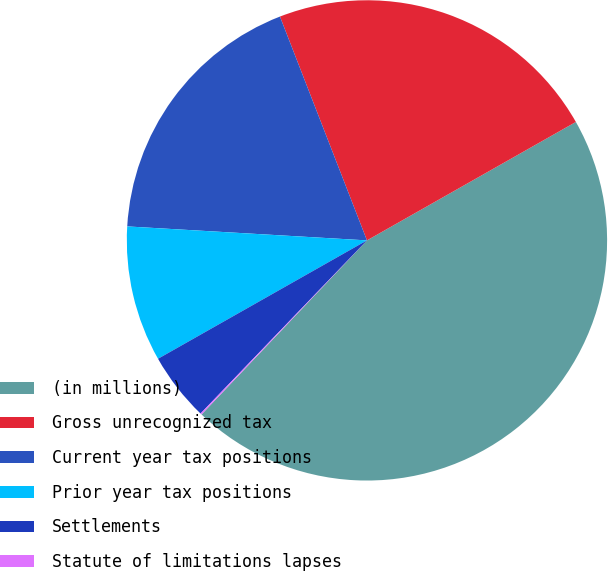Convert chart to OTSL. <chart><loc_0><loc_0><loc_500><loc_500><pie_chart><fcel>(in millions)<fcel>Gross unrecognized tax<fcel>Current year tax positions<fcel>Prior year tax positions<fcel>Settlements<fcel>Statute of limitations lapses<nl><fcel>45.3%<fcel>22.69%<fcel>18.17%<fcel>9.13%<fcel>4.61%<fcel>0.09%<nl></chart> 